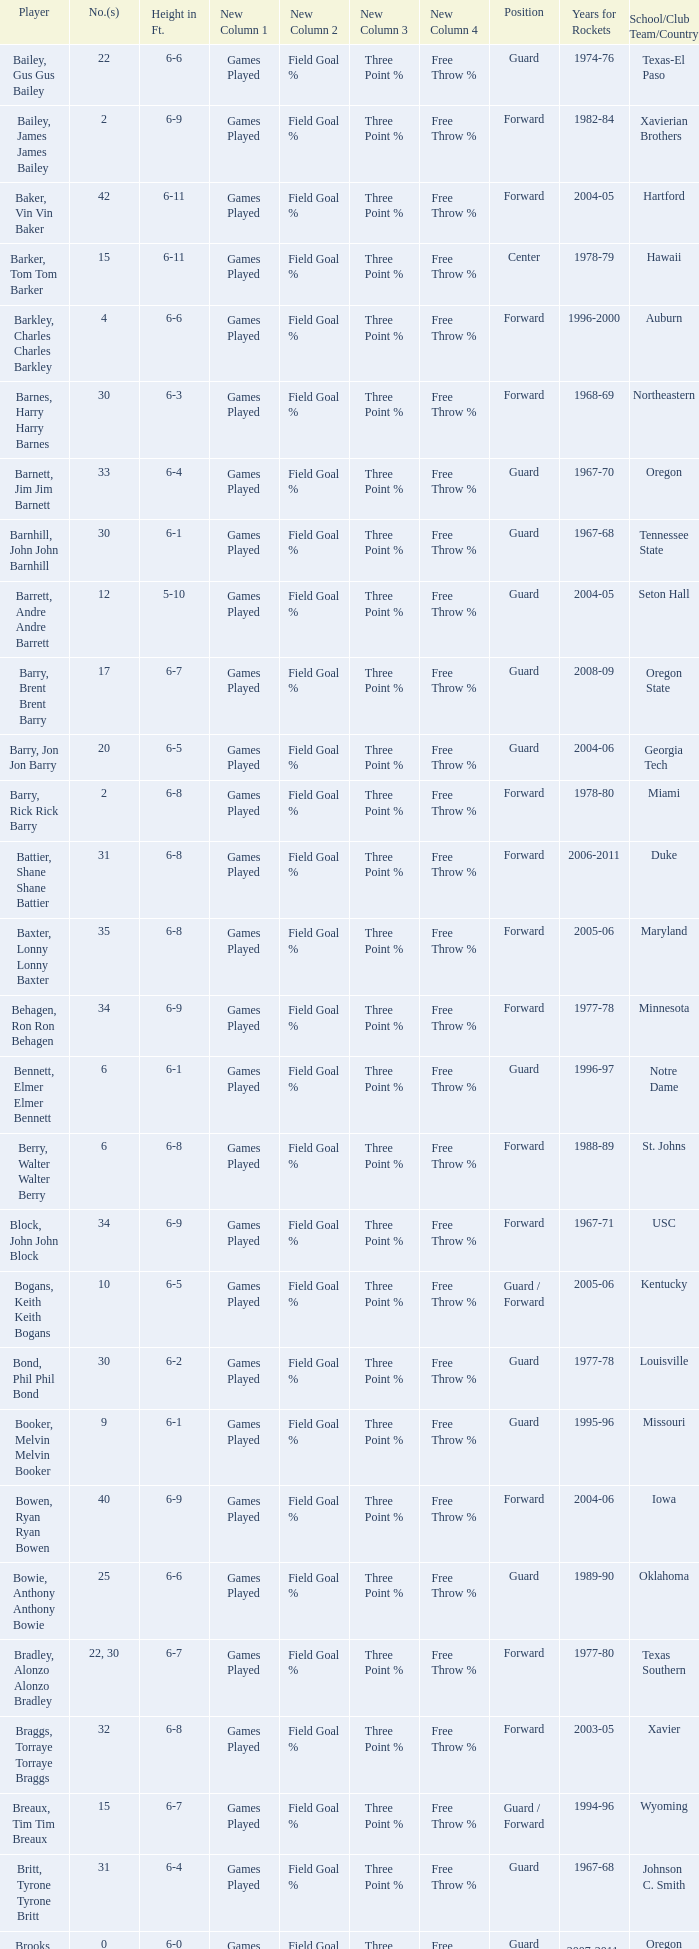What position is number 35 whose height is 6-6? Forward. 